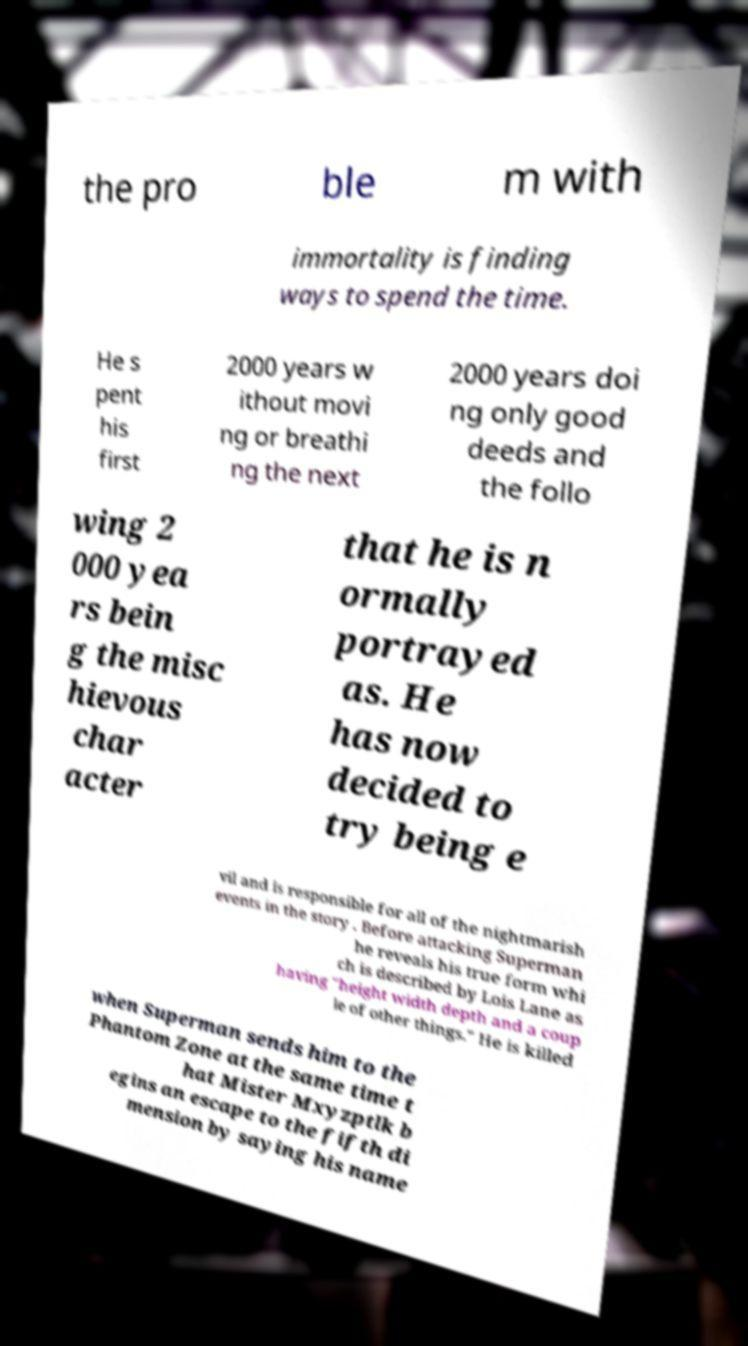Could you assist in decoding the text presented in this image and type it out clearly? the pro ble m with immortality is finding ways to spend the time. He s pent his first 2000 years w ithout movi ng or breathi ng the next 2000 years doi ng only good deeds and the follo wing 2 000 yea rs bein g the misc hievous char acter that he is n ormally portrayed as. He has now decided to try being e vil and is responsible for all of the nightmarish events in the story . Before attacking Superman he reveals his true form whi ch is described by Lois Lane as having "height width depth and a coup le of other things." He is killed when Superman sends him to the Phantom Zone at the same time t hat Mister Mxyzptlk b egins an escape to the fifth di mension by saying his name 